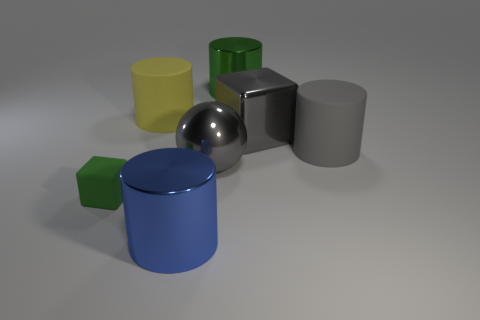Does the big object that is in front of the small matte block have the same shape as the large matte thing that is left of the gray matte thing?
Make the answer very short. Yes. There is a matte object that is on the left side of the large gray matte cylinder and on the right side of the tiny green rubber block; what shape is it?
Give a very brief answer. Cylinder. Are there any metallic objects that have the same size as the blue cylinder?
Give a very brief answer. Yes. There is a tiny rubber block; does it have the same color as the metallic object on the left side of the large gray sphere?
Provide a short and direct response. No. What material is the big yellow thing?
Offer a very short reply. Rubber. There is a big matte cylinder that is in front of the big yellow object; what is its color?
Your answer should be compact. Gray. What number of big cubes are the same color as the tiny rubber object?
Offer a very short reply. 0. What number of big things are behind the large gray matte object and to the left of the shiny cube?
Ensure brevity in your answer.  2. What shape is the gray metal thing that is the same size as the metal block?
Provide a short and direct response. Sphere. How big is the gray metallic ball?
Your answer should be very brief. Large. 